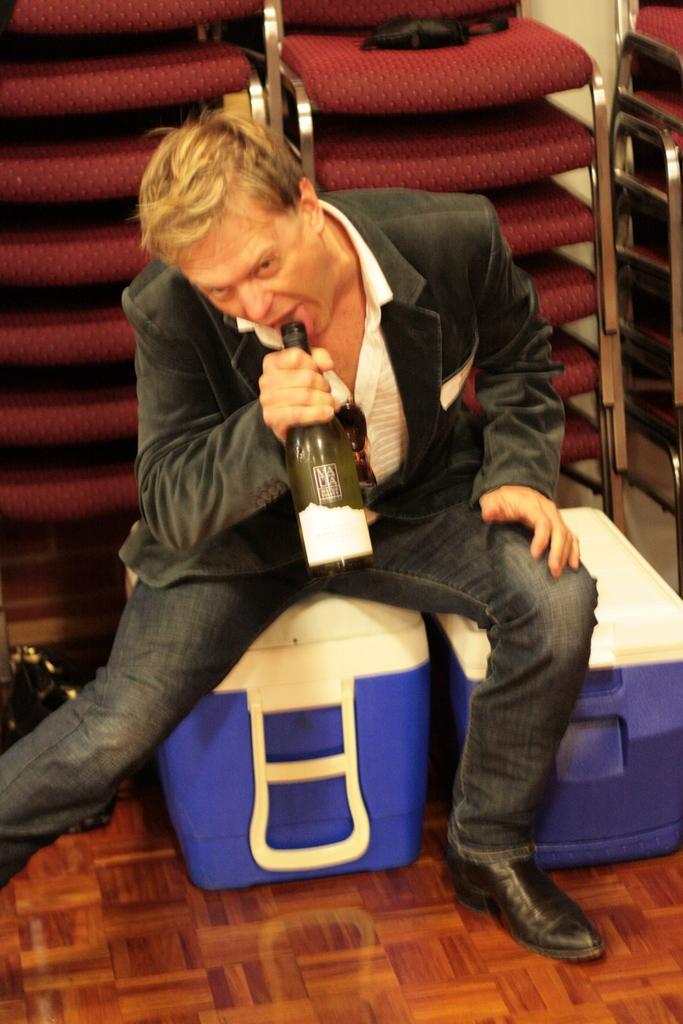Please provide a concise description of this image. In this image I can see a man wearing suit, sitting and holding a bottle in his hand. In the background I can see chairs. On the left side of the image there is a black color bag. 